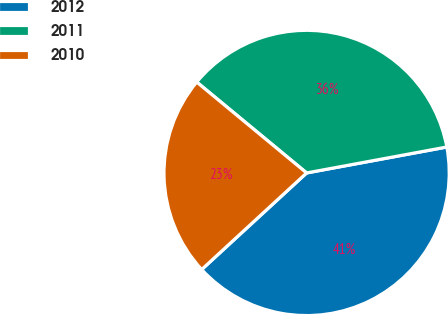<chart> <loc_0><loc_0><loc_500><loc_500><pie_chart><fcel>2012<fcel>2011<fcel>2010<nl><fcel>41.07%<fcel>36.09%<fcel>22.84%<nl></chart> 